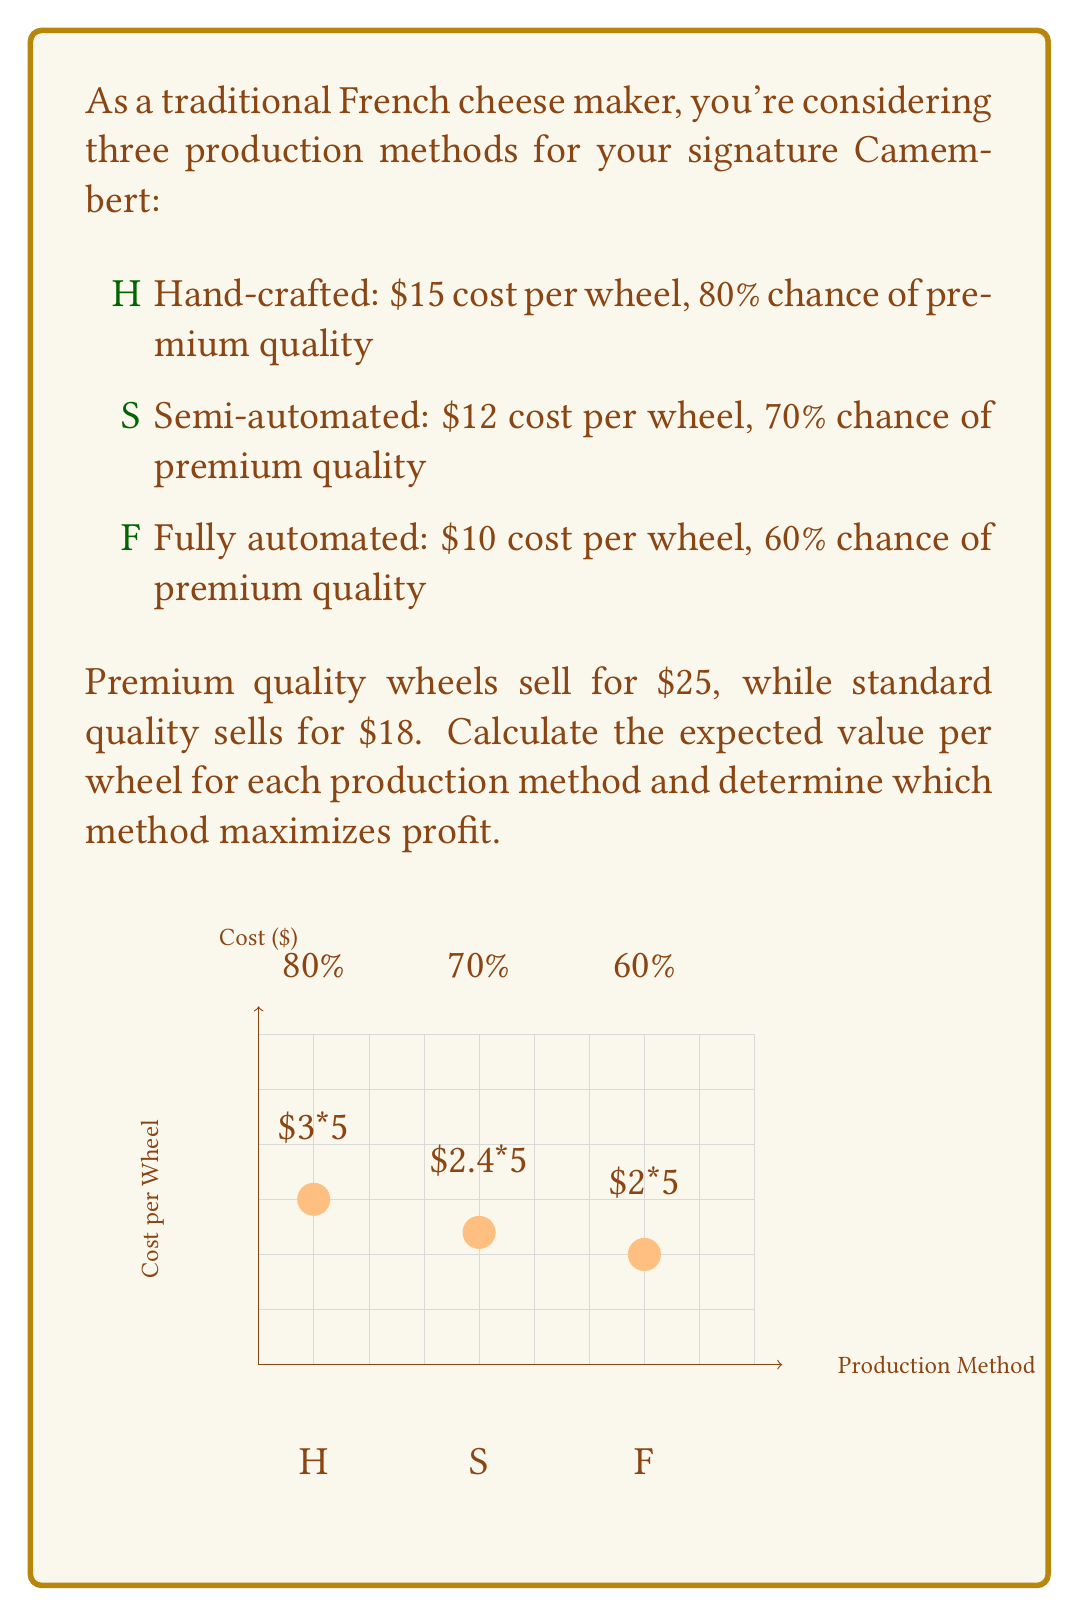Help me with this question. Let's calculate the expected value for each method:

1. Hand-crafted (H):
   - Premium probability: 80% = 0.8
   - Standard probability: 20% = 0.2
   - Expected revenue: $0.8 \cdot \$25 + 0.2 \cdot \$18 = \$23.60$
   - Cost: $\$15$
   - Expected profit: $\$23.60 - \$15 = \$8.60$

2. Semi-automated (S):
   - Premium probability: 70% = 0.7
   - Standard probability: 30% = 0.3
   - Expected revenue: $0.7 \cdot \$25 + 0.3 \cdot \$18 = \$22.90$
   - Cost: $\$12$
   - Expected profit: $\$22.90 - \$12 = \$10.90$

3. Fully automated (F):
   - Premium probability: 60% = 0.6
   - Standard probability: 40% = 0.4
   - Expected revenue: $0.6 \cdot \$25 + 0.4 \cdot \$18 = \$22.20$
   - Cost: $\$10$
   - Expected profit: $\$22.20 - \$10 = \$12.20$

The expected value (EV) for each method is the expected profit per wheel:

$$\begin{align}
EV(H) &= \$8.60 \\
EV(S) &= \$10.90 \\
EV(F) &= \$12.20
\end{align}$$

The method that maximizes profit is the one with the highest expected value, which is the fully automated method (F) with an expected profit of $\$12.20$ per wheel.
Answer: Fully automated (F): $\$12.20$ per wheel 